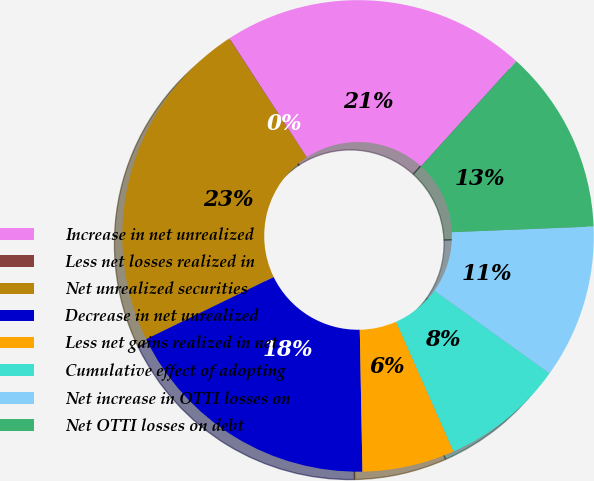Convert chart. <chart><loc_0><loc_0><loc_500><loc_500><pie_chart><fcel>Increase in net unrealized<fcel>Less net losses realized in<fcel>Net unrealized securities<fcel>Decrease in net unrealized<fcel>Less net gains realized in net<fcel>Cumulative effect of adopting<fcel>Net increase in OTTI losses on<fcel>Net OTTI losses on debt<nl><fcel>20.9%<fcel>0.03%<fcel>23.0%<fcel>18.08%<fcel>6.34%<fcel>8.45%<fcel>10.55%<fcel>12.65%<nl></chart> 